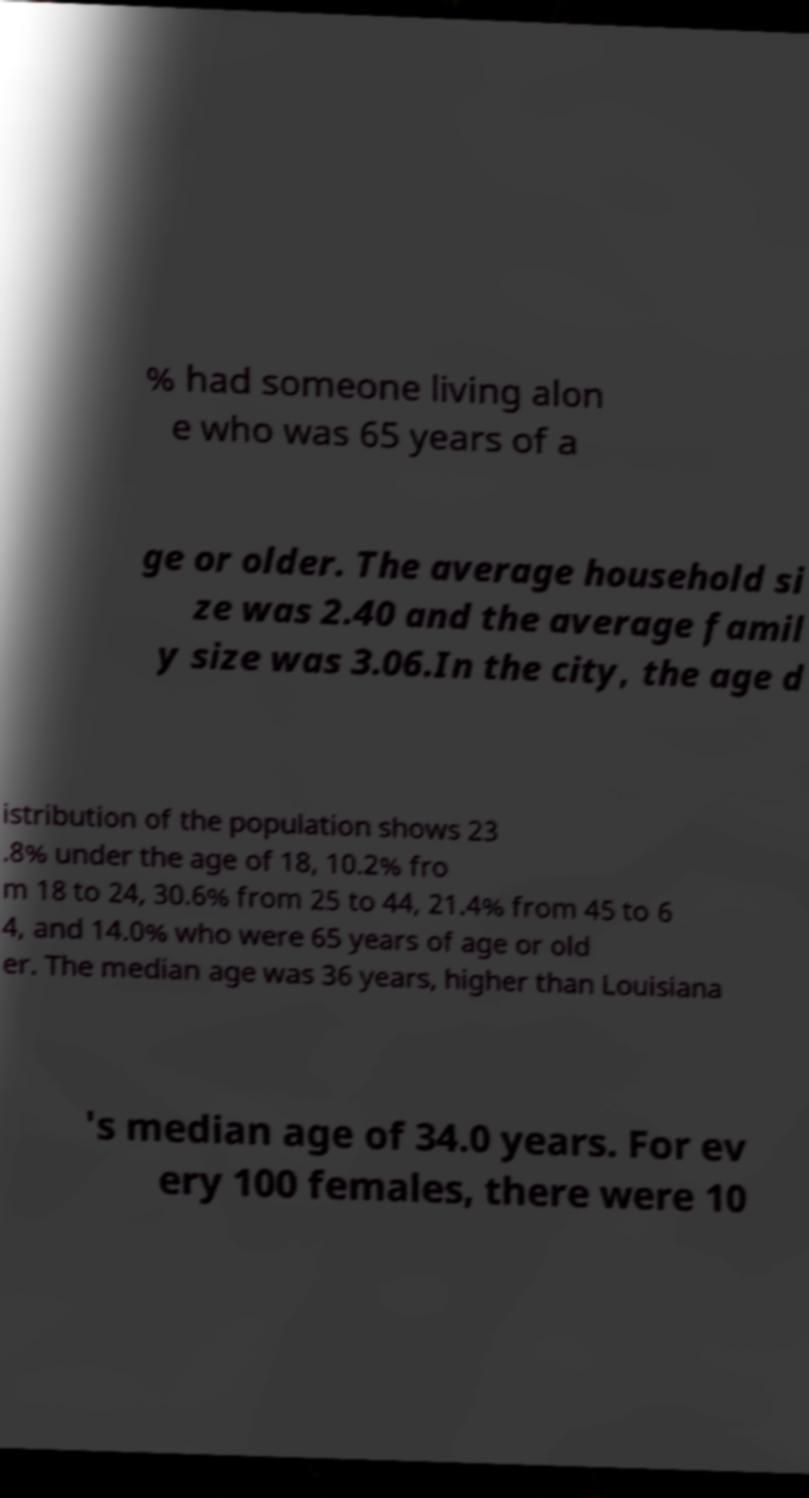There's text embedded in this image that I need extracted. Can you transcribe it verbatim? % had someone living alon e who was 65 years of a ge or older. The average household si ze was 2.40 and the average famil y size was 3.06.In the city, the age d istribution of the population shows 23 .8% under the age of 18, 10.2% fro m 18 to 24, 30.6% from 25 to 44, 21.4% from 45 to 6 4, and 14.0% who were 65 years of age or old er. The median age was 36 years, higher than Louisiana 's median age of 34.0 years. For ev ery 100 females, there were 10 